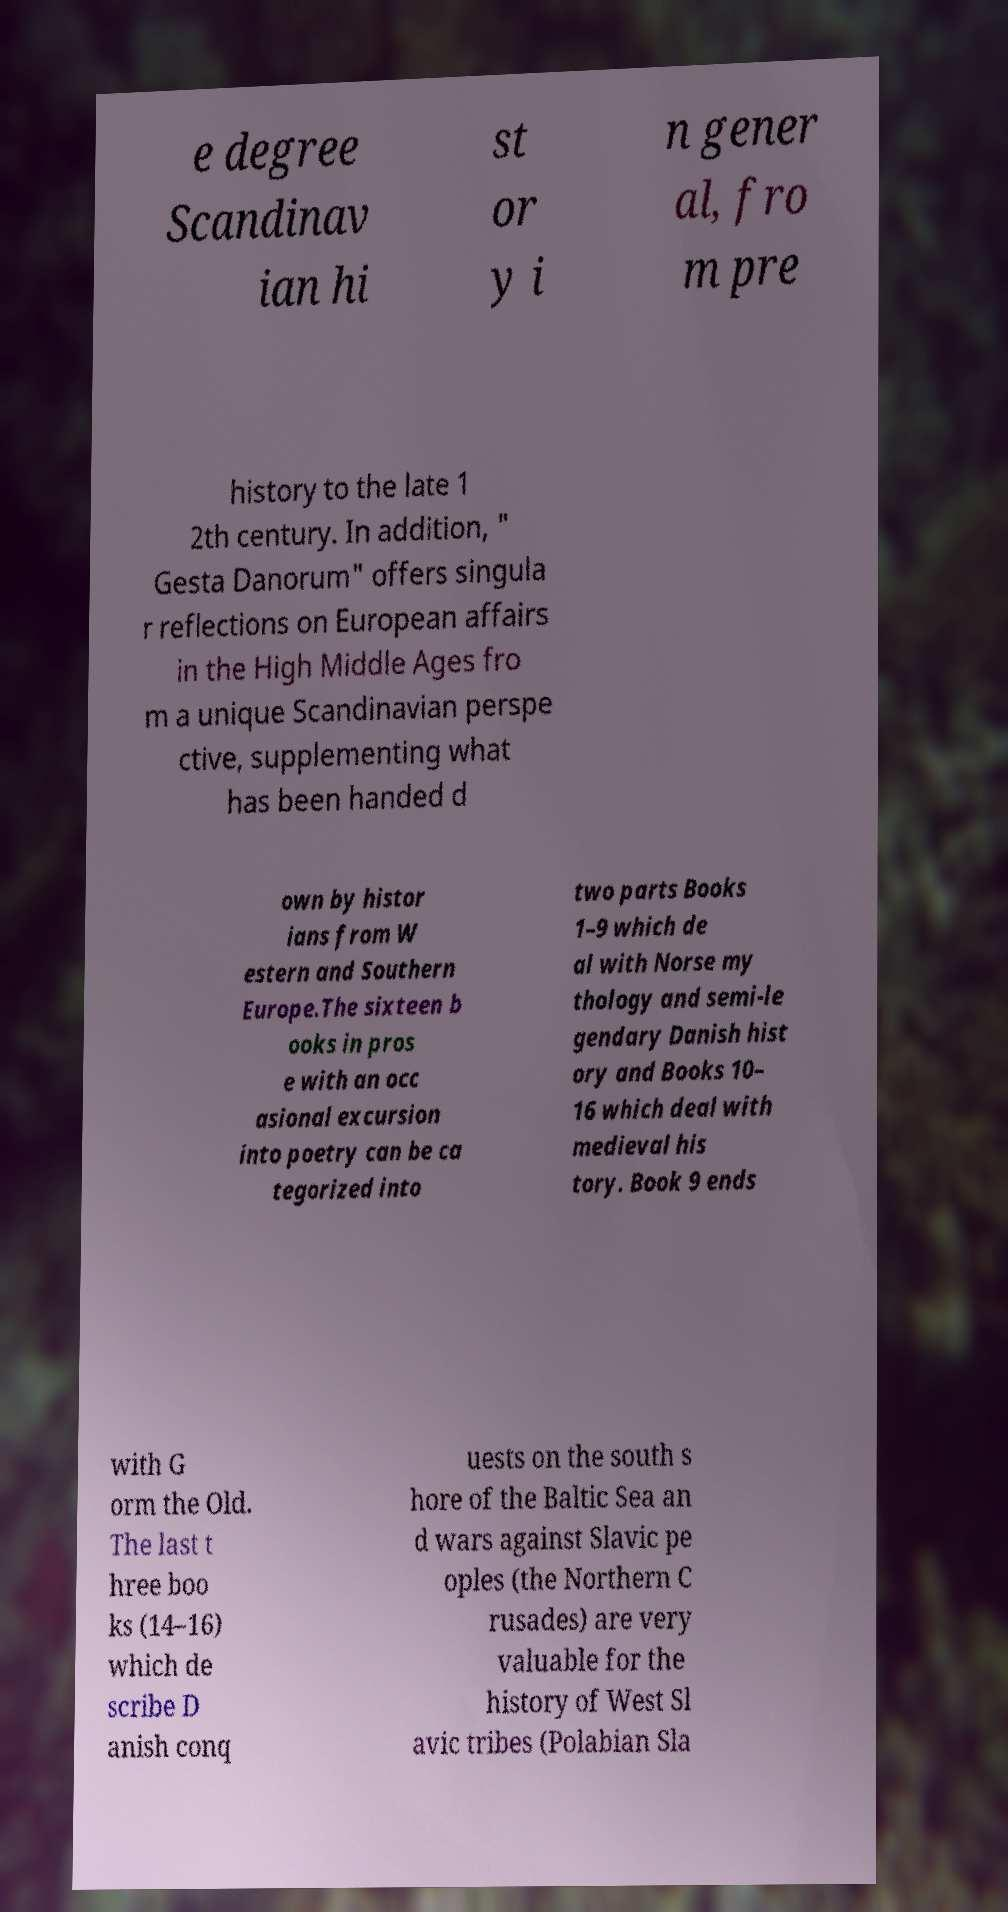Please read and relay the text visible in this image. What does it say? e degree Scandinav ian hi st or y i n gener al, fro m pre history to the late 1 2th century. In addition, " Gesta Danorum" offers singula r reflections on European affairs in the High Middle Ages fro m a unique Scandinavian perspe ctive, supplementing what has been handed d own by histor ians from W estern and Southern Europe.The sixteen b ooks in pros e with an occ asional excursion into poetry can be ca tegorized into two parts Books 1–9 which de al with Norse my thology and semi-le gendary Danish hist ory and Books 10– 16 which deal with medieval his tory. Book 9 ends with G orm the Old. The last t hree boo ks (14–16) which de scribe D anish conq uests on the south s hore of the Baltic Sea an d wars against Slavic pe oples (the Northern C rusades) are very valuable for the history of West Sl avic tribes (Polabian Sla 